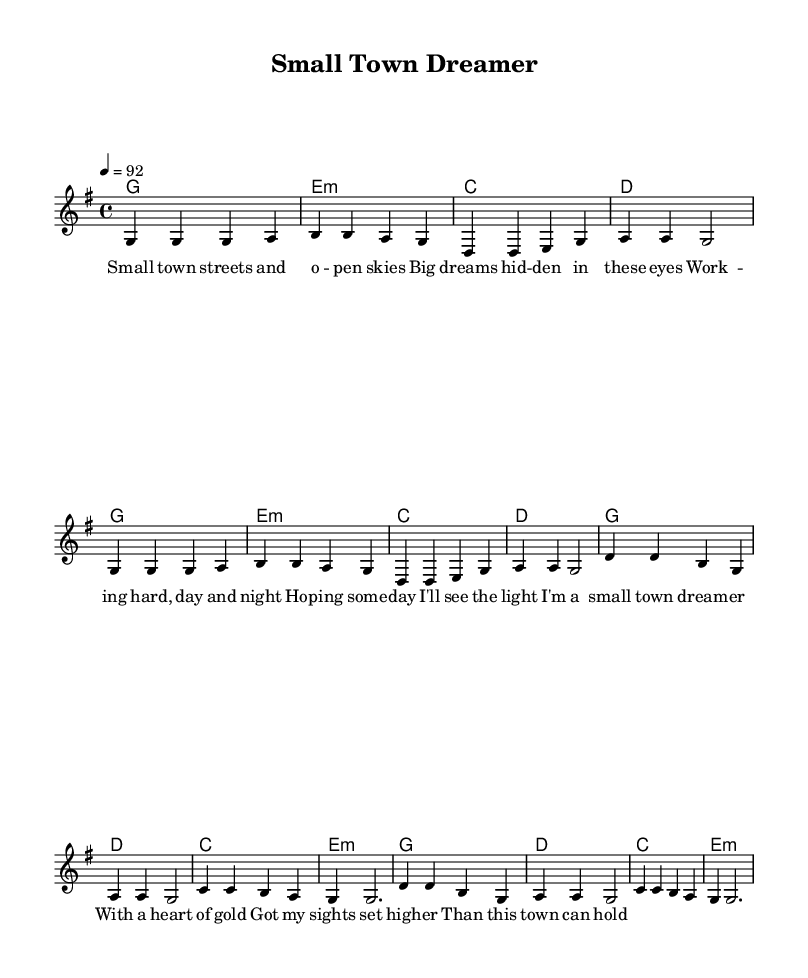What is the key signature of this music? The key signature is G major, which contains one sharp (F#). This is indicated at the beginning of the score.
Answer: G major What is the time signature of this music? The time signature is 4/4, which is shown at the start of the score. This indicates that there are four beats in each measure.
Answer: 4/4 What is the tempo marking of this music? The tempo marking indicates a speed of 92 beats per minute, which is specified as "4 = 92" at the beginning of the score.
Answer: 92 How many measures are in the verse section? The verse section consists of 8 measures in total, as counted through the notes provided before the chorus starts.
Answer: 8 What is the last chord of the chorus? The last chord of the chorus is an E minor chord. This can be identified through the chord sequence listed under the melody notes.
Answer: E minor How many lines of lyrics are included in the chorus? The chorus contains four lines of lyrics, each corresponding to the melody in the chorus section. This can be observed in the lyrics placement under the melody notes for the chorus.
Answer: 4 